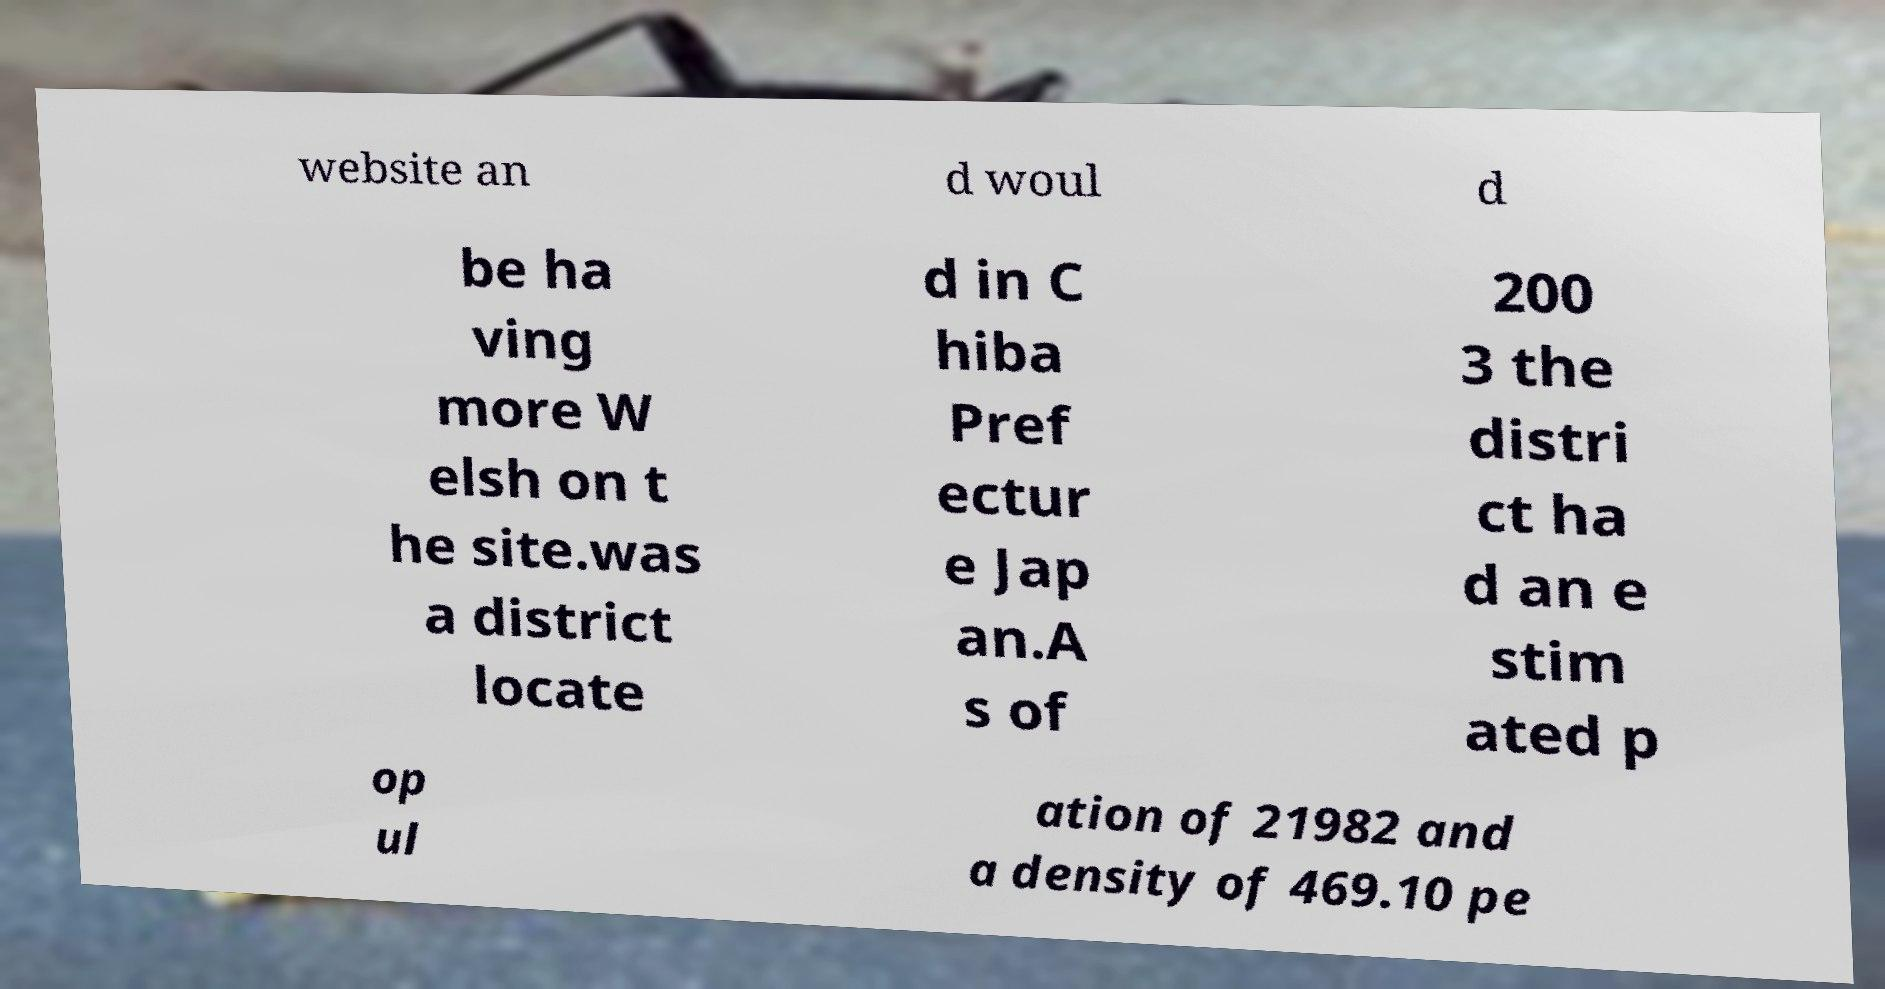Can you read and provide the text displayed in the image?This photo seems to have some interesting text. Can you extract and type it out for me? website an d woul d be ha ving more W elsh on t he site.was a district locate d in C hiba Pref ectur e Jap an.A s of 200 3 the distri ct ha d an e stim ated p op ul ation of 21982 and a density of 469.10 pe 